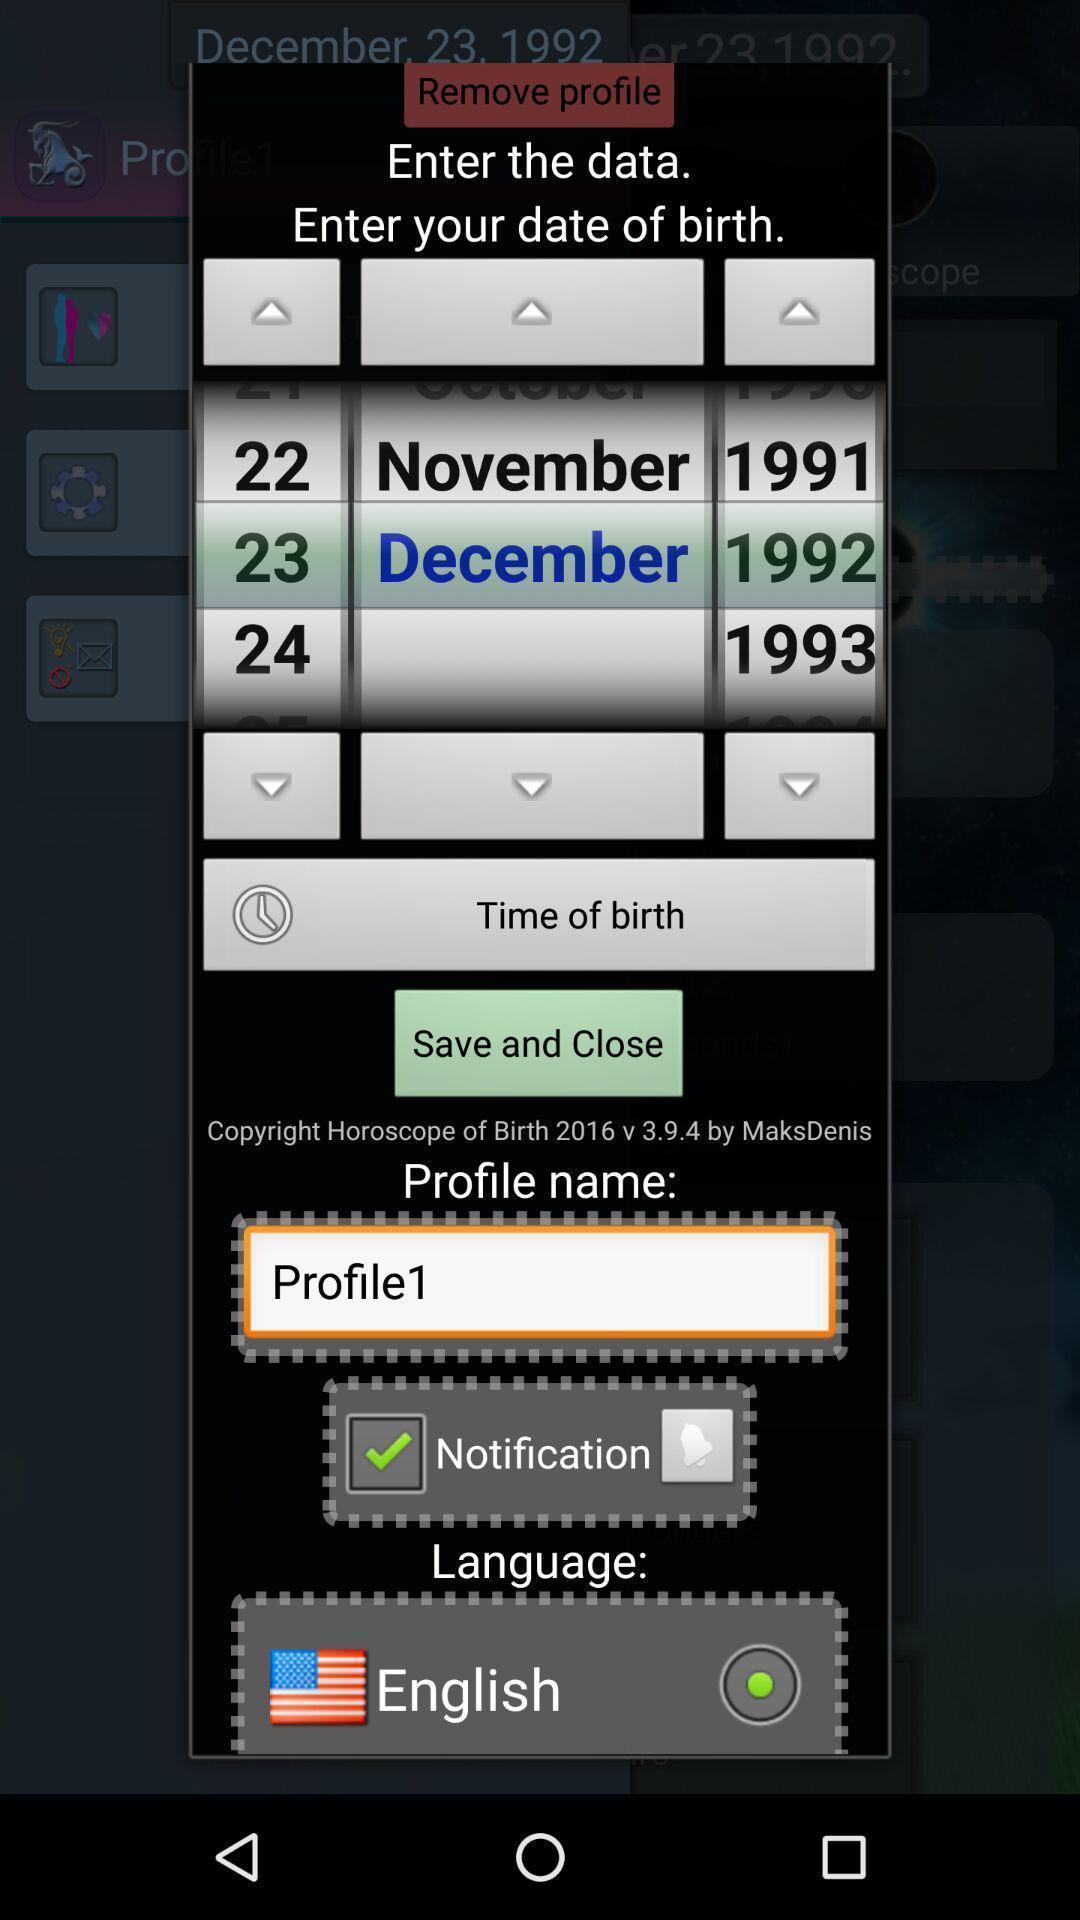Describe this image in words. Profile editor page with personal informations. 